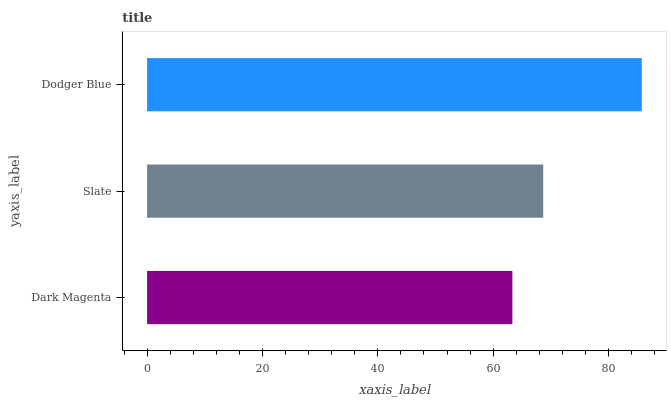Is Dark Magenta the minimum?
Answer yes or no. Yes. Is Dodger Blue the maximum?
Answer yes or no. Yes. Is Slate the minimum?
Answer yes or no. No. Is Slate the maximum?
Answer yes or no. No. Is Slate greater than Dark Magenta?
Answer yes or no. Yes. Is Dark Magenta less than Slate?
Answer yes or no. Yes. Is Dark Magenta greater than Slate?
Answer yes or no. No. Is Slate less than Dark Magenta?
Answer yes or no. No. Is Slate the high median?
Answer yes or no. Yes. Is Slate the low median?
Answer yes or no. Yes. Is Dodger Blue the high median?
Answer yes or no. No. Is Dodger Blue the low median?
Answer yes or no. No. 